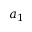<formula> <loc_0><loc_0><loc_500><loc_500>a _ { 1 }</formula> 